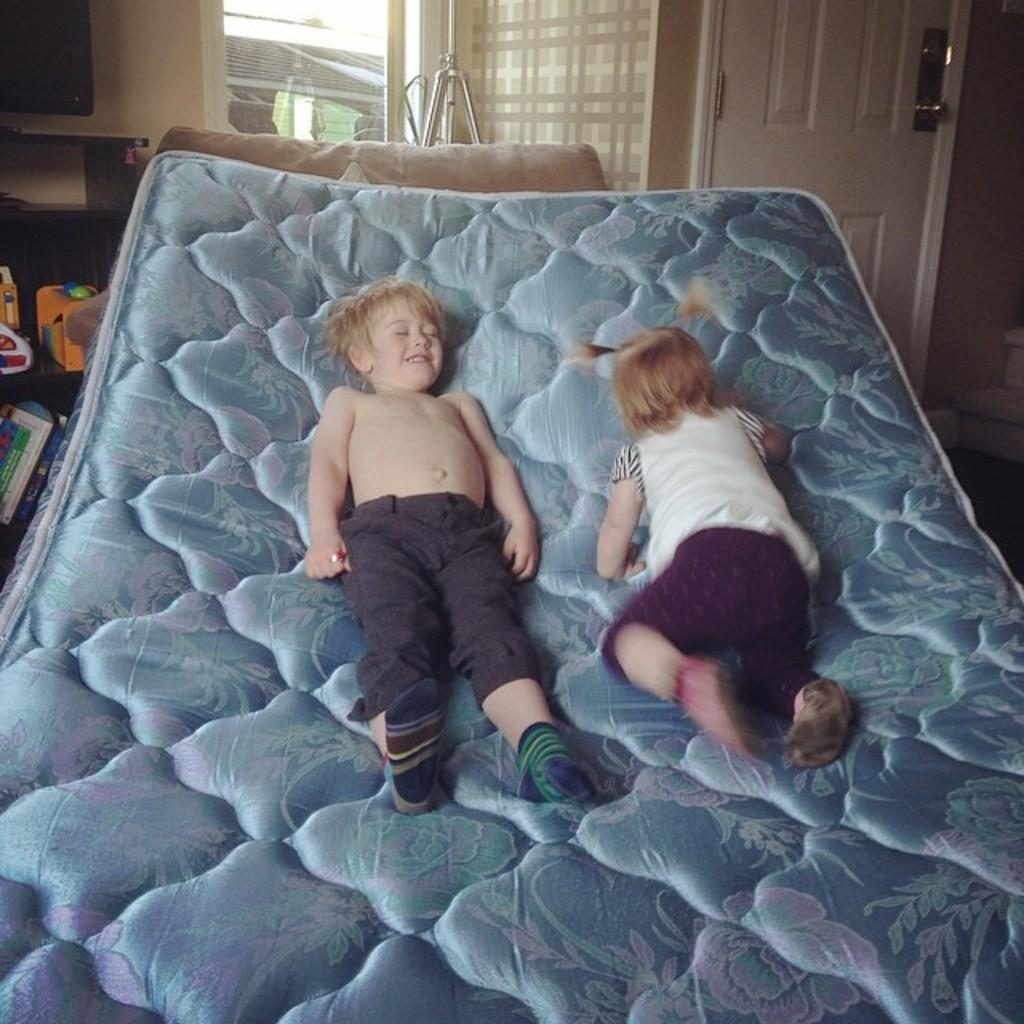What is present in the image? There are kids in the image. What are the kids doing in the image? The kids are lying on a mattress. What type of chess piece is visible on the wrist of one of the kids in the image? There is no chess piece visible on the wrist of any of the kids in the image. What type of mine is present in the image? There is no mine present in the image; it features kids lying on a mattress. 